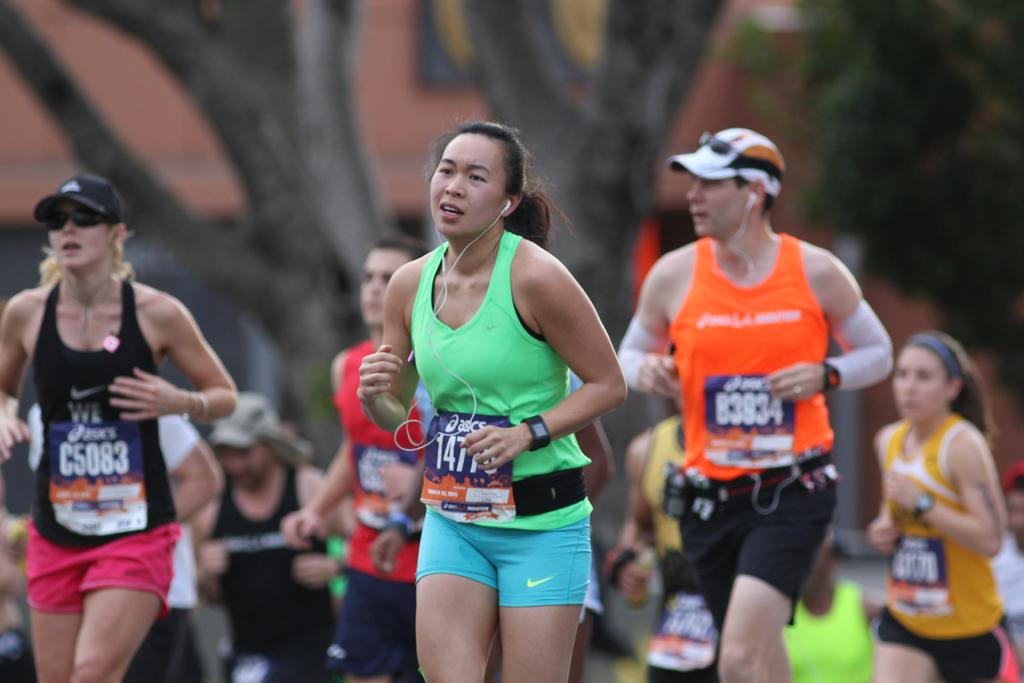<image>
Write a terse but informative summary of the picture. a lady running with the numbers 147 on her 